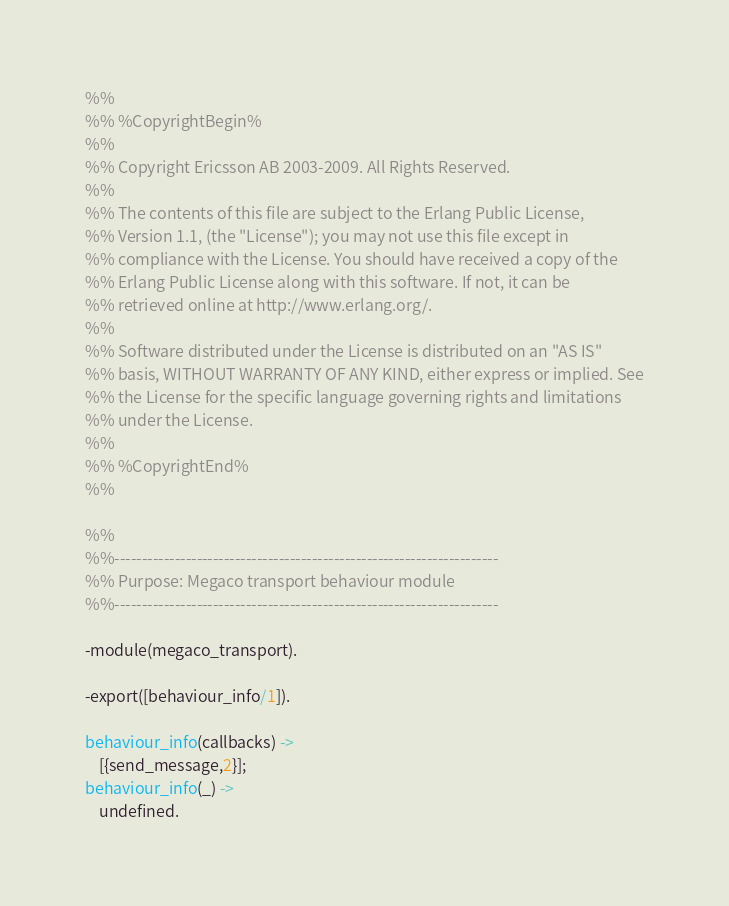<code> <loc_0><loc_0><loc_500><loc_500><_Erlang_>%%
%% %CopyrightBegin%
%% 
%% Copyright Ericsson AB 2003-2009. All Rights Reserved.
%% 
%% The contents of this file are subject to the Erlang Public License,
%% Version 1.1, (the "License"); you may not use this file except in
%% compliance with the License. You should have received a copy of the
%% Erlang Public License along with this software. If not, it can be
%% retrieved online at http://www.erlang.org/.
%% 
%% Software distributed under the License is distributed on an "AS IS"
%% basis, WITHOUT WARRANTY OF ANY KIND, either express or implied. See
%% the License for the specific language governing rights and limitations
%% under the License.
%% 
%% %CopyrightEnd%
%%

%%
%%----------------------------------------------------------------------
%% Purpose: Megaco transport behaviour module
%%----------------------------------------------------------------------

-module(megaco_transport).

-export([behaviour_info/1]).

behaviour_info(callbacks) ->
    [{send_message,2}];
behaviour_info(_) ->
    undefined.
</code> 